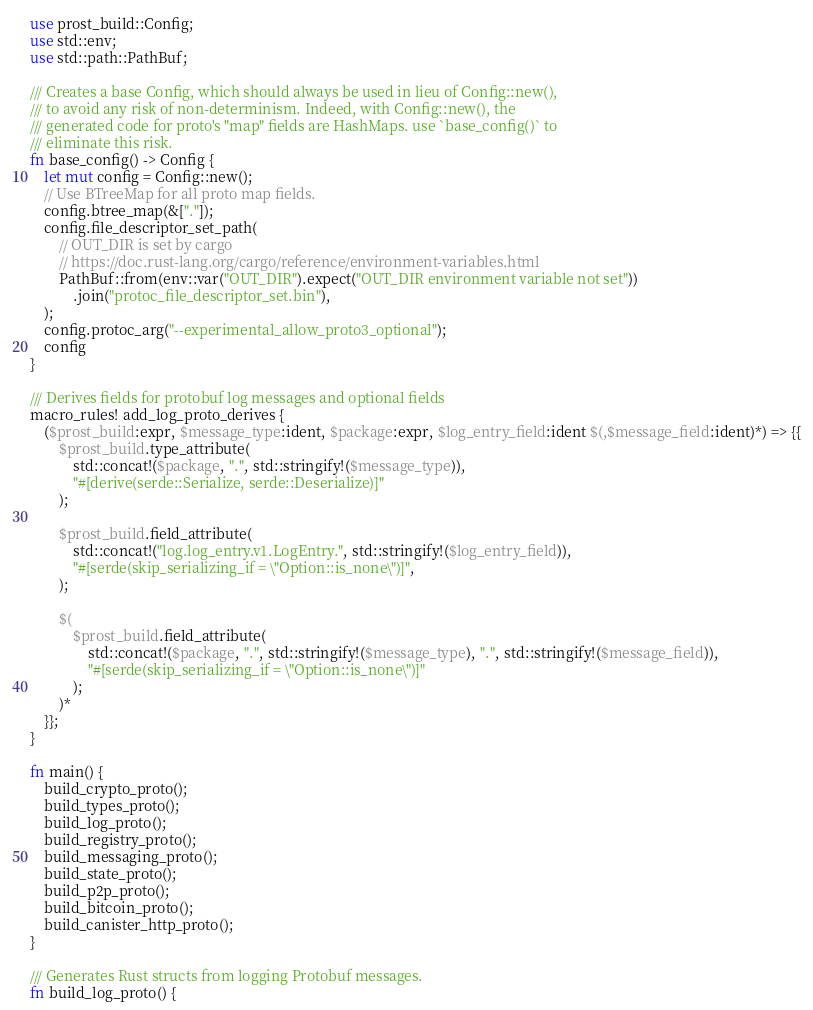<code> <loc_0><loc_0><loc_500><loc_500><_Rust_>use prost_build::Config;
use std::env;
use std::path::PathBuf;

/// Creates a base Config, which should always be used in lieu of Config::new(),
/// to avoid any risk of non-determinism. Indeed, with Config::new(), the
/// generated code for proto's "map" fields are HashMaps. use `base_config()` to
/// eliminate this risk.
fn base_config() -> Config {
    let mut config = Config::new();
    // Use BTreeMap for all proto map fields.
    config.btree_map(&["."]);
    config.file_descriptor_set_path(
        // OUT_DIR is set by cargo
        // https://doc.rust-lang.org/cargo/reference/environment-variables.html
        PathBuf::from(env::var("OUT_DIR").expect("OUT_DIR environment variable not set"))
            .join("protoc_file_descriptor_set.bin"),
    );
    config.protoc_arg("--experimental_allow_proto3_optional");
    config
}

/// Derives fields for protobuf log messages and optional fields
macro_rules! add_log_proto_derives {
    ($prost_build:expr, $message_type:ident, $package:expr, $log_entry_field:ident $(,$message_field:ident)*) => {{
        $prost_build.type_attribute(
            std::concat!($package, ".", std::stringify!($message_type)),
            "#[derive(serde::Serialize, serde::Deserialize)]"
        );

        $prost_build.field_attribute(
            std::concat!("log.log_entry.v1.LogEntry.", std::stringify!($log_entry_field)),
            "#[serde(skip_serializing_if = \"Option::is_none\")]",
        );

        $(
            $prost_build.field_attribute(
                std::concat!($package, ".", std::stringify!($message_type), ".", std::stringify!($message_field)),
                "#[serde(skip_serializing_if = \"Option::is_none\")]"
            );
        )*
    }};
}

fn main() {
    build_crypto_proto();
    build_types_proto();
    build_log_proto();
    build_registry_proto();
    build_messaging_proto();
    build_state_proto();
    build_p2p_proto();
    build_bitcoin_proto();
    build_canister_http_proto();
}

/// Generates Rust structs from logging Protobuf messages.
fn build_log_proto() {</code> 